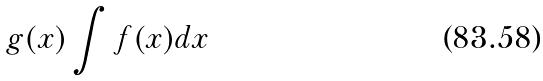Convert formula to latex. <formula><loc_0><loc_0><loc_500><loc_500>g ( x ) \int f ( x ) d x</formula> 